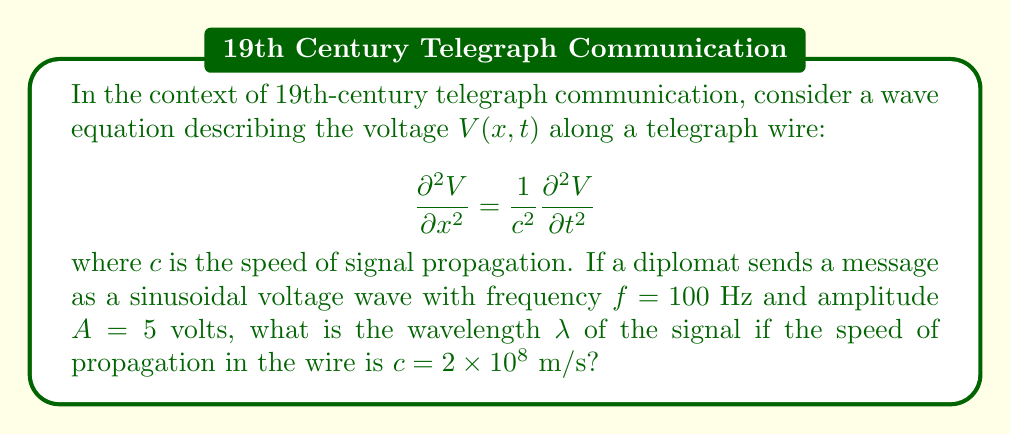Can you solve this math problem? To solve this problem, we'll use the wave equation and the relationship between wave speed, frequency, and wavelength.

Step 1: Recall the wave equation for a sinusoidal wave:
$$V(x,t) = A \sin(kx - \omega t)$$
where $k$ is the wave number and $\omega$ is the angular frequency.

Step 2: The wave number $k$ is related to the wavelength $\lambda$ by:
$$k = \frac{2\pi}{\lambda}$$

Step 3: The angular frequency $\omega$ is related to the frequency $f$ by:
$$\omega = 2\pi f$$

Step 4: For a wave traveling at speed $c$, we have the relationship:
$$c = \lambda f$$

Step 5: Rearrange this equation to solve for $\lambda$:
$$\lambda = \frac{c}{f}$$

Step 6: Substitute the given values:
$$\lambda = \frac{2 \times 10^8 \text{ m/s}}{100 \text{ Hz}}$$

Step 7: Calculate the result:
$$\lambda = 2 \times 10^6 \text{ m} = 2000 \text{ km}$$

This wavelength represents the distance between successive peaks of the voltage wave along the telegraph wire.
Answer: $\lambda = 2000 \text{ km}$ 